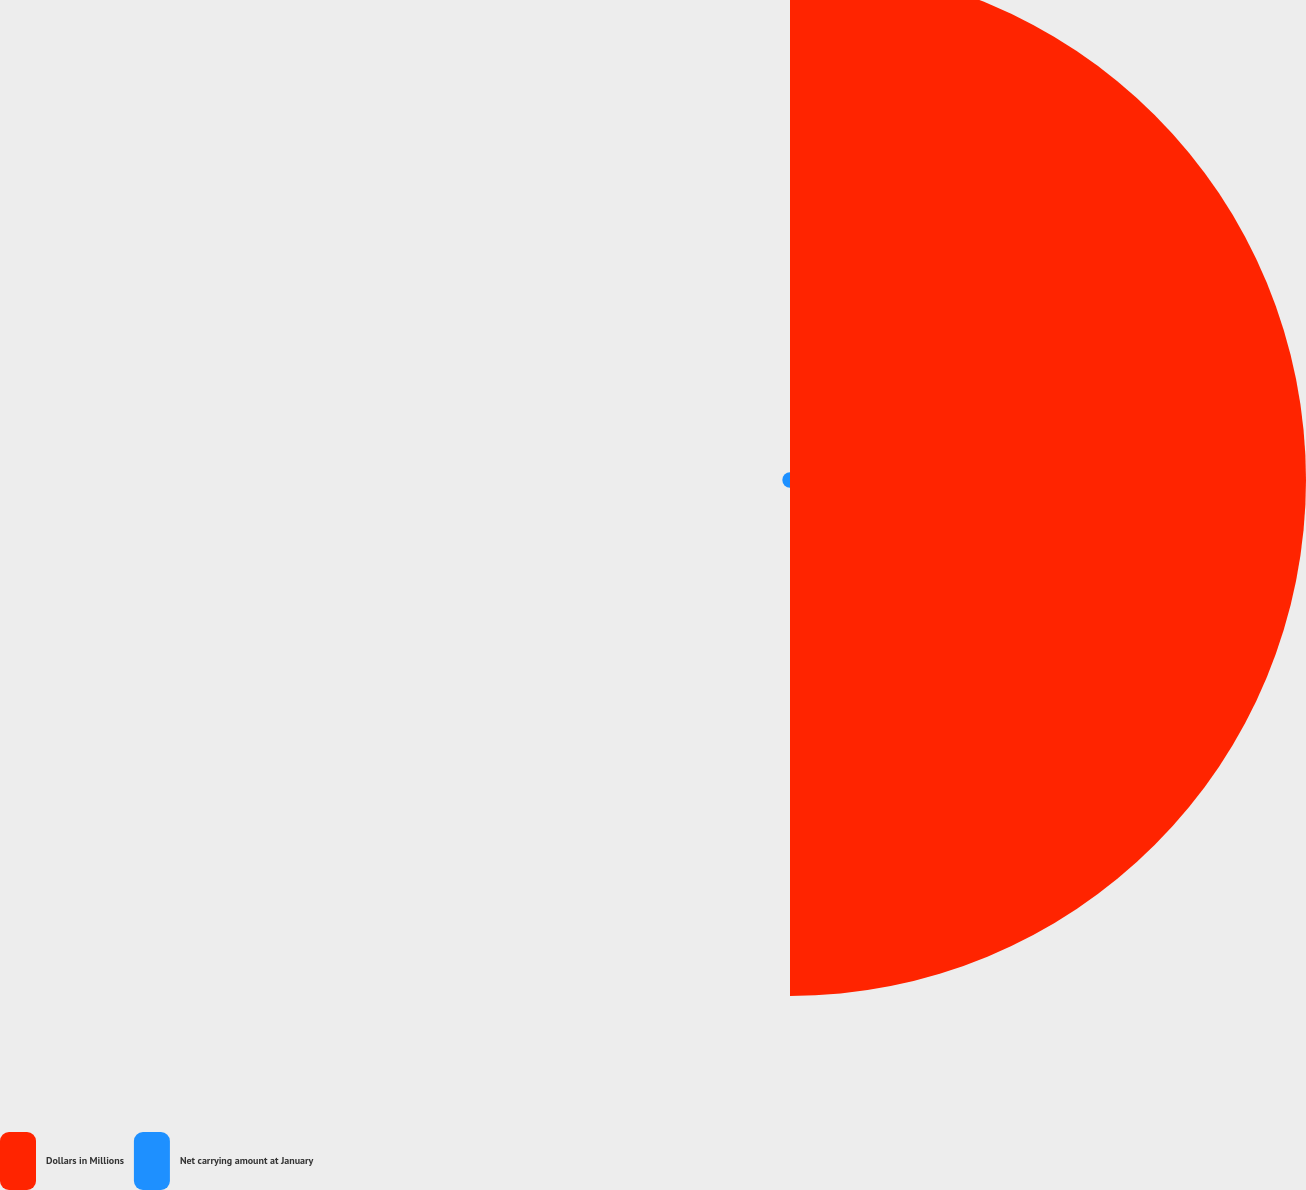Convert chart to OTSL. <chart><loc_0><loc_0><loc_500><loc_500><pie_chart><fcel>Dollars in Millions<fcel>Net carrying amount at January<nl><fcel>98.53%<fcel>1.47%<nl></chart> 